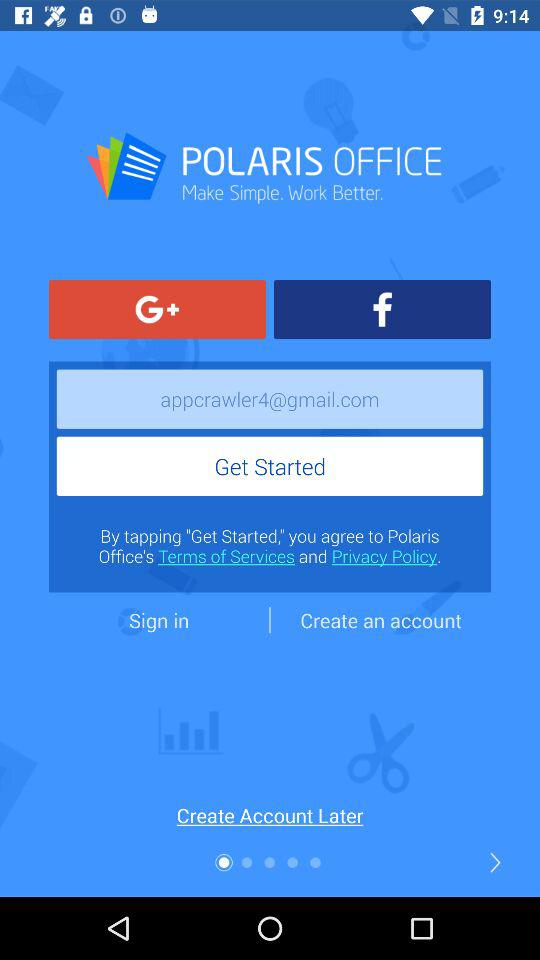What is the Gmail account that is used? The used Gmail account is appcrawler4@gmail.com. 